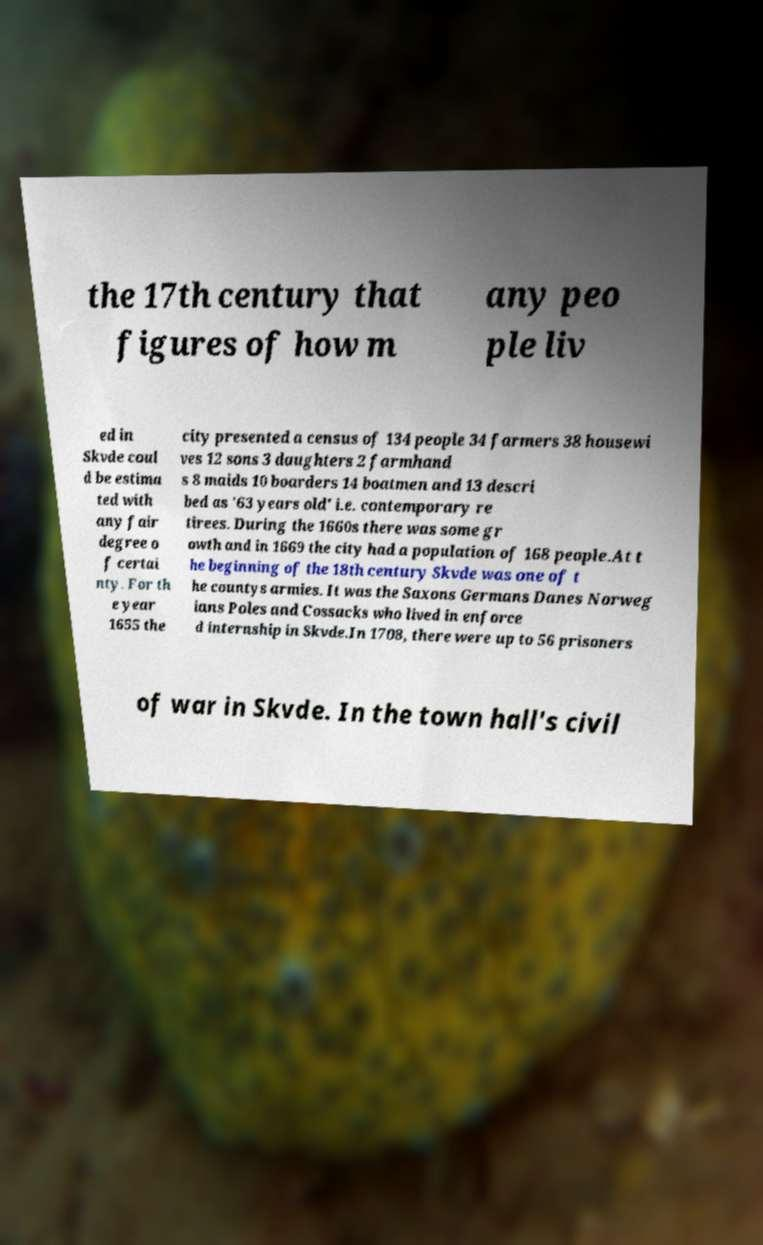Please identify and transcribe the text found in this image. the 17th century that figures of how m any peo ple liv ed in Skvde coul d be estima ted with any fair degree o f certai nty. For th e year 1655 the city presented a census of 134 people 34 farmers 38 housewi ves 12 sons 3 daughters 2 farmhand s 8 maids 10 boarders 14 boatmen and 13 descri bed as '63 years old' i.e. contemporary re tirees. During the 1660s there was some gr owth and in 1669 the city had a population of 168 people.At t he beginning of the 18th century Skvde was one of t he countys armies. It was the Saxons Germans Danes Norweg ians Poles and Cossacks who lived in enforce d internship in Skvde.In 1708, there were up to 56 prisoners of war in Skvde. In the town hall's civil 